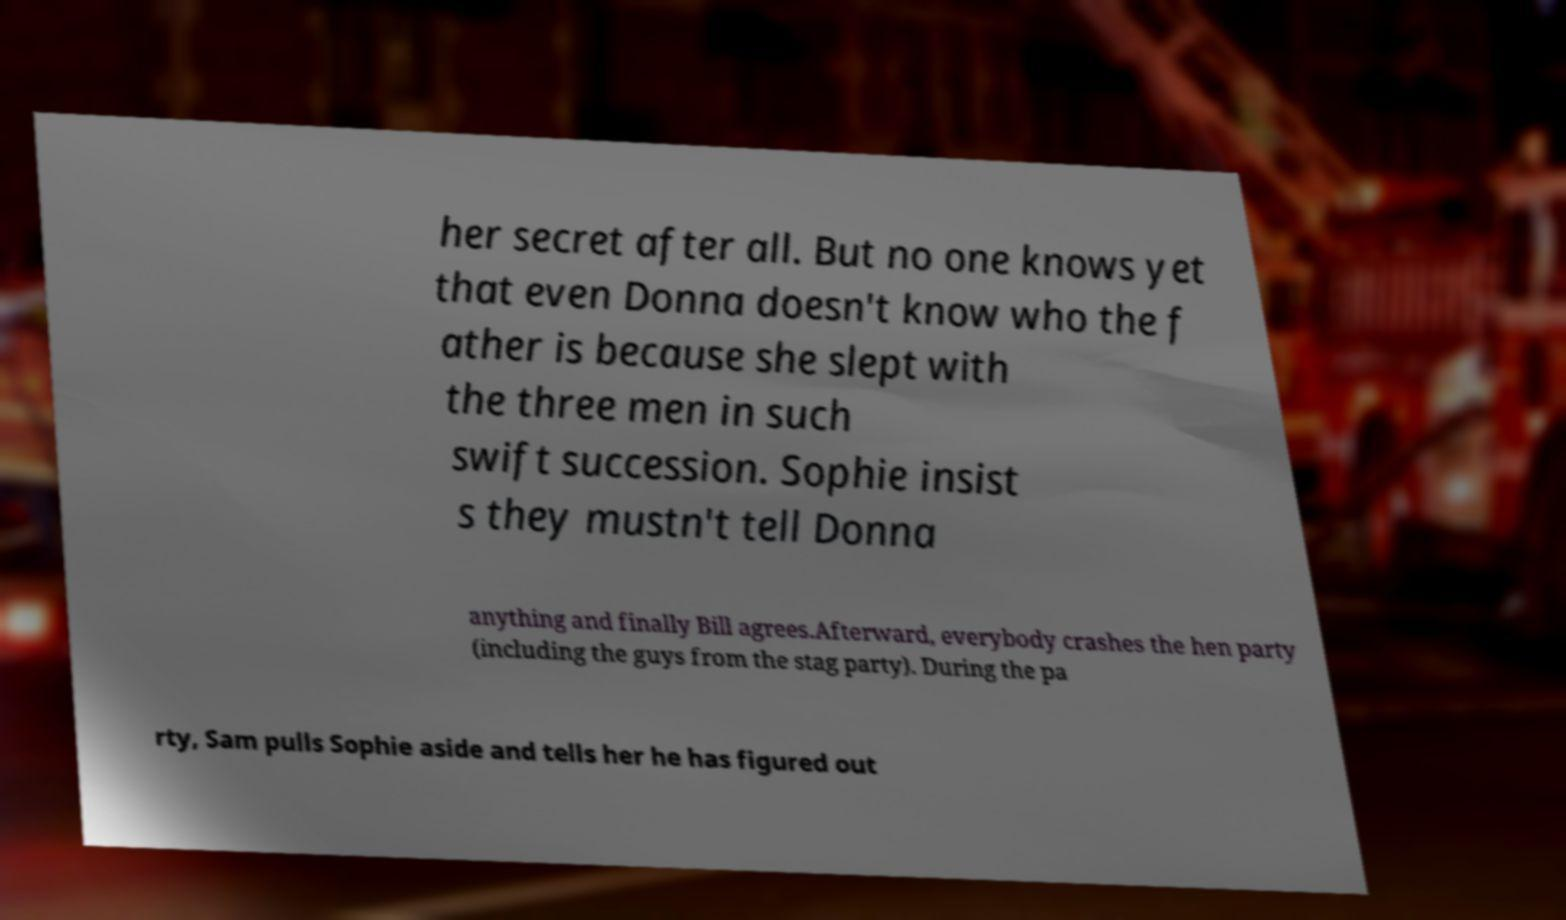Could you extract and type out the text from this image? her secret after all. But no one knows yet that even Donna doesn't know who the f ather is because she slept with the three men in such swift succession. Sophie insist s they mustn't tell Donna anything and finally Bill agrees.Afterward, everybody crashes the hen party (including the guys from the stag party). During the pa rty, Sam pulls Sophie aside and tells her he has figured out 